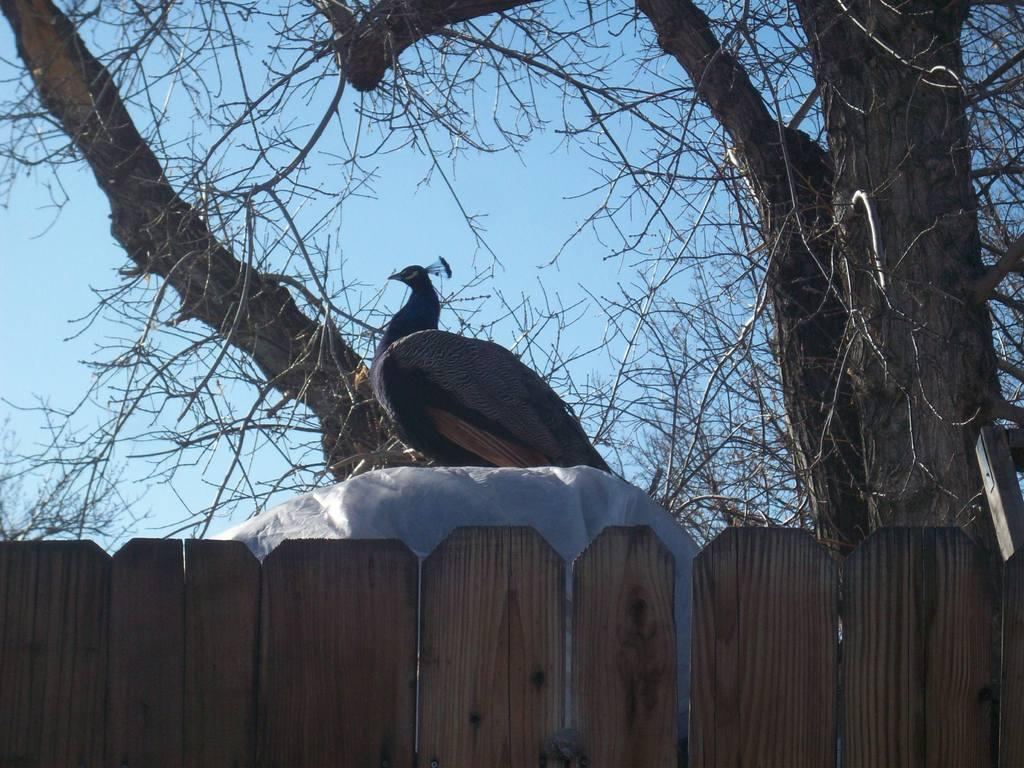What type of animal is in the image? There is a peacock in the image. What is the wooden structure in the image? There is a wooden fence in the image. What type of vegetation is present in the image? There are trees in the image. What can be seen in the background of the image? The sky is visible in the background of the image. What type of voice does the peacock have in the image? The image is static, so it does not capture any sounds or voices. The peacock's voice cannot be determined from the image. 